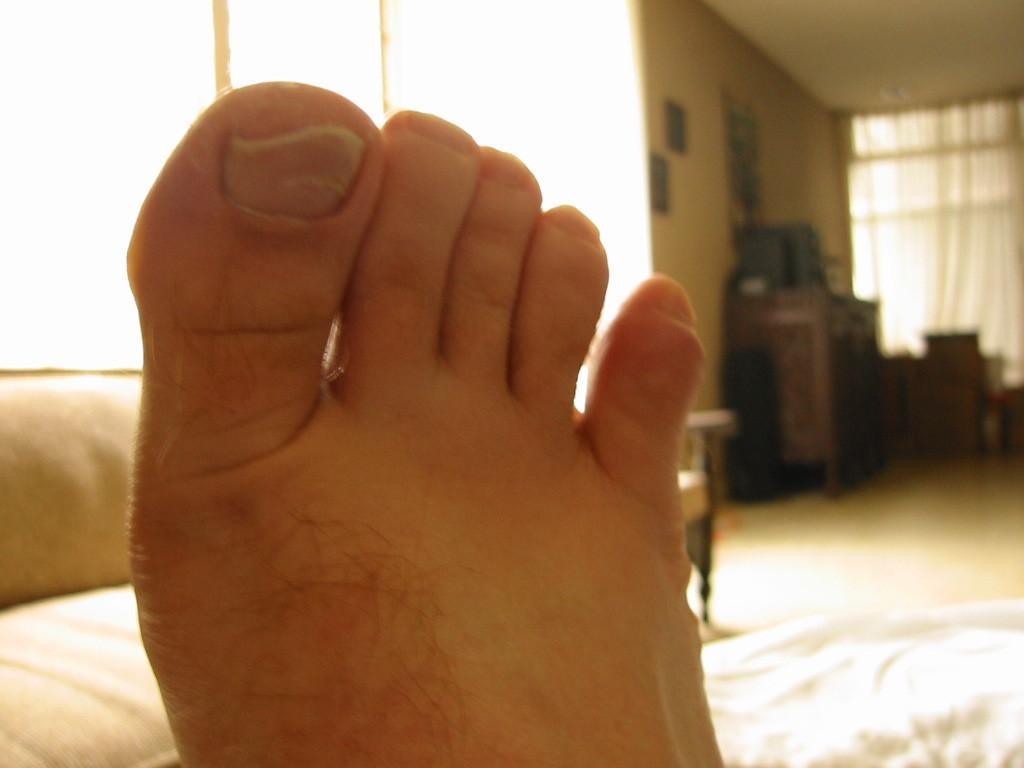How would you summarize this image in a sentence or two? In this image, I can see a person's foot. This looks like a couch. I think this is a blanket. I can see the frames attached to the wall. This looks like a cupboard. In the background, I can see the curtains hanging. 